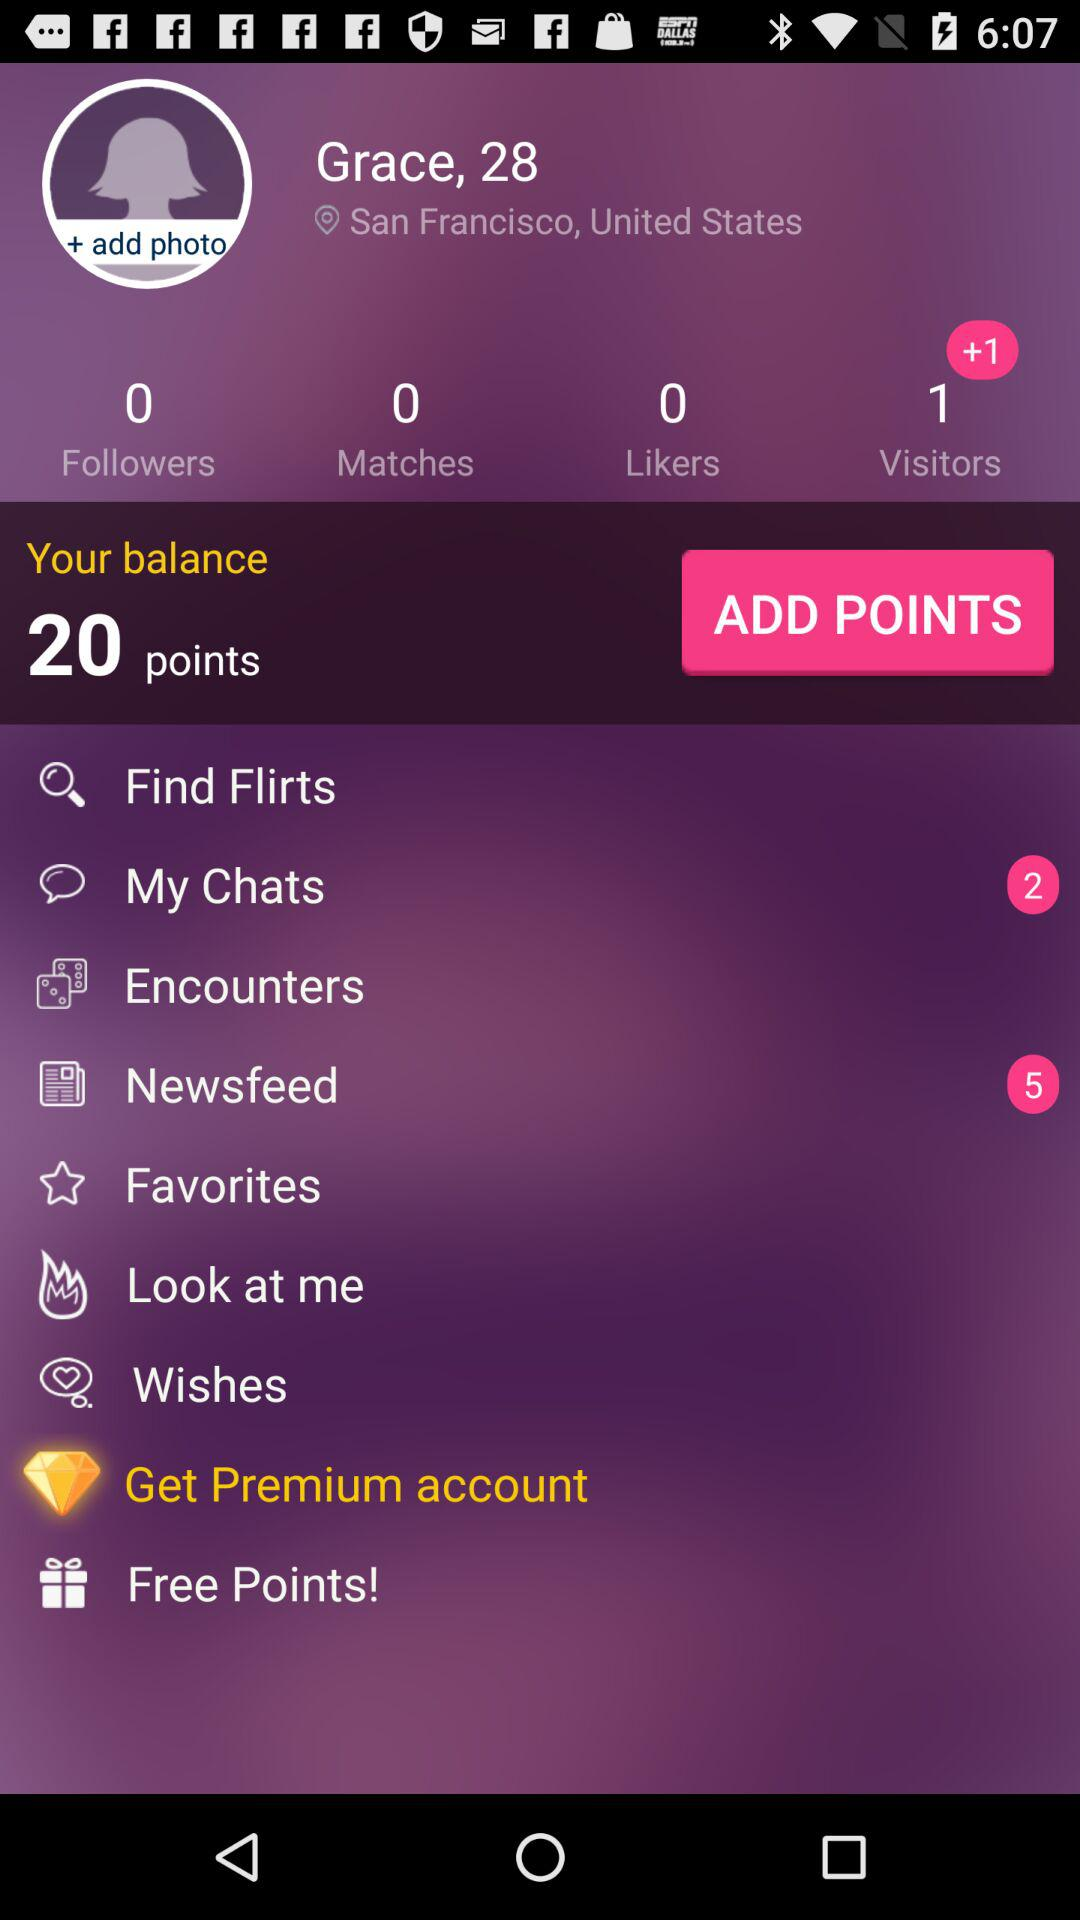What's the number of matches? The number of matches is 0. 